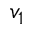Convert formula to latex. <formula><loc_0><loc_0><loc_500><loc_500>v _ { 1 }</formula> 